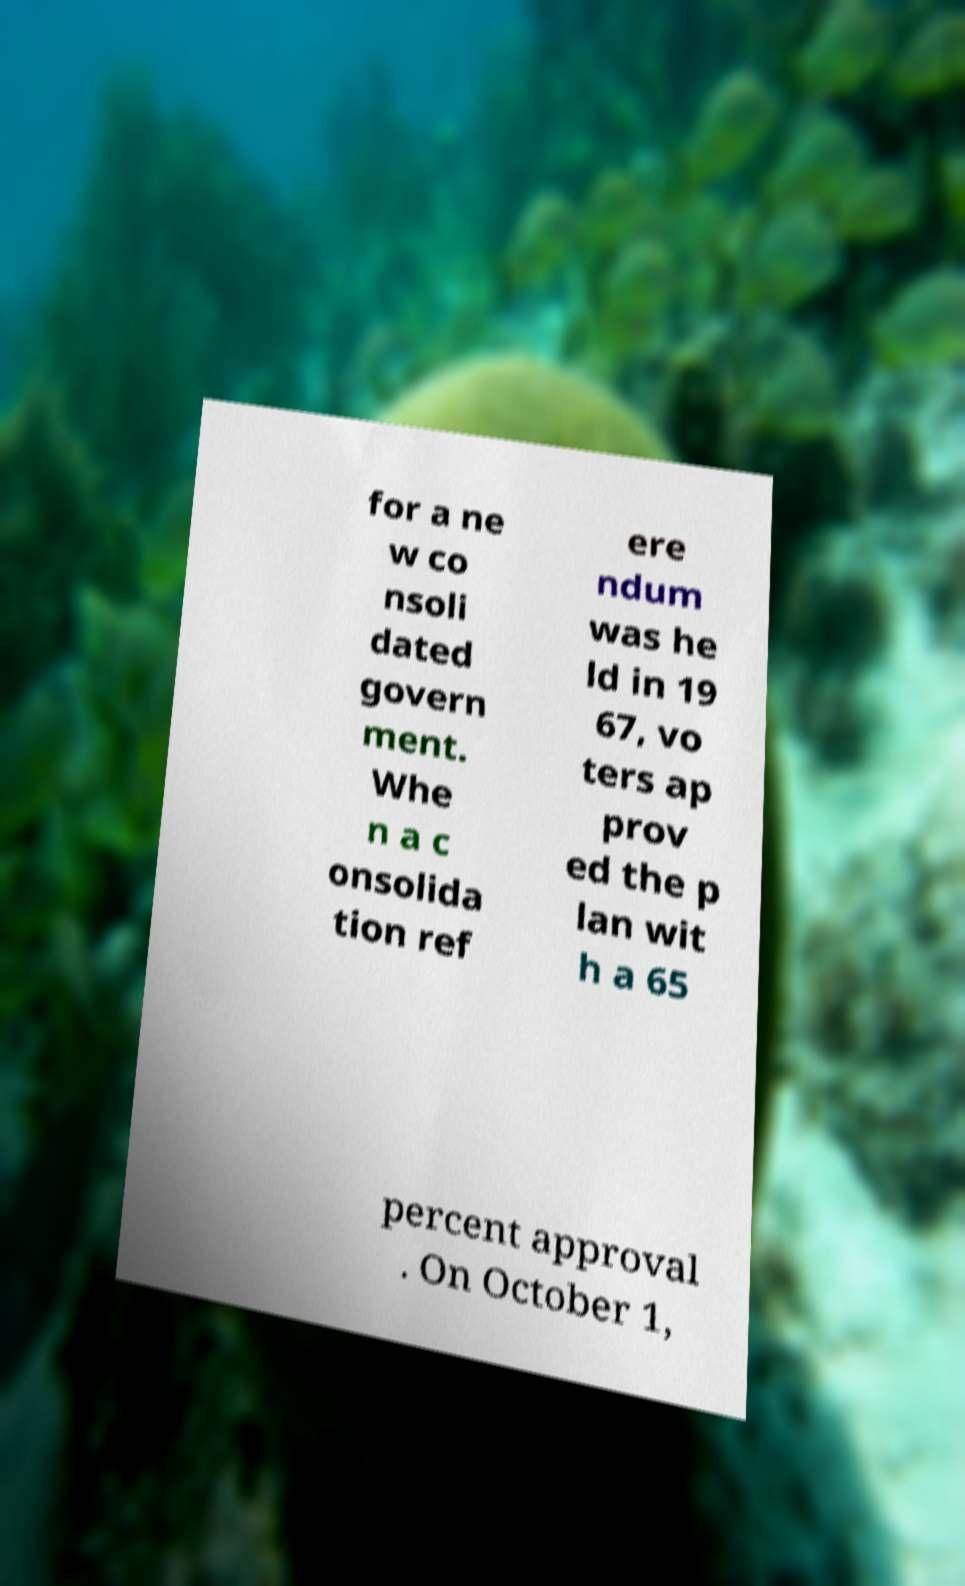Please read and relay the text visible in this image. What does it say? for a ne w co nsoli dated govern ment. Whe n a c onsolida tion ref ere ndum was he ld in 19 67, vo ters ap prov ed the p lan wit h a 65 percent approval . On October 1, 